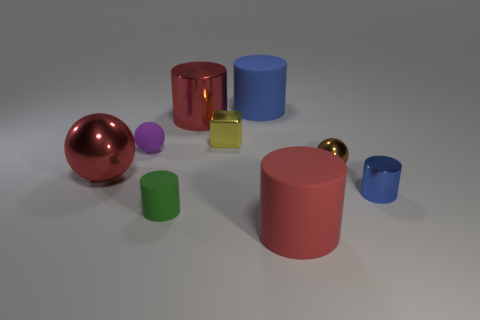Subtract all purple rubber balls. How many balls are left? 2 Subtract all purple spheres. How many spheres are left? 2 Subtract 1 blocks. How many blocks are left? 0 Subtract all green balls. How many blue cylinders are left? 2 Subtract all tiny brown shiny spheres. Subtract all tiny green rubber things. How many objects are left? 7 Add 6 tiny matte balls. How many tiny matte balls are left? 7 Add 4 green objects. How many green objects exist? 5 Subtract 0 yellow cylinders. How many objects are left? 9 Subtract all balls. How many objects are left? 6 Subtract all red spheres. Subtract all green cylinders. How many spheres are left? 2 